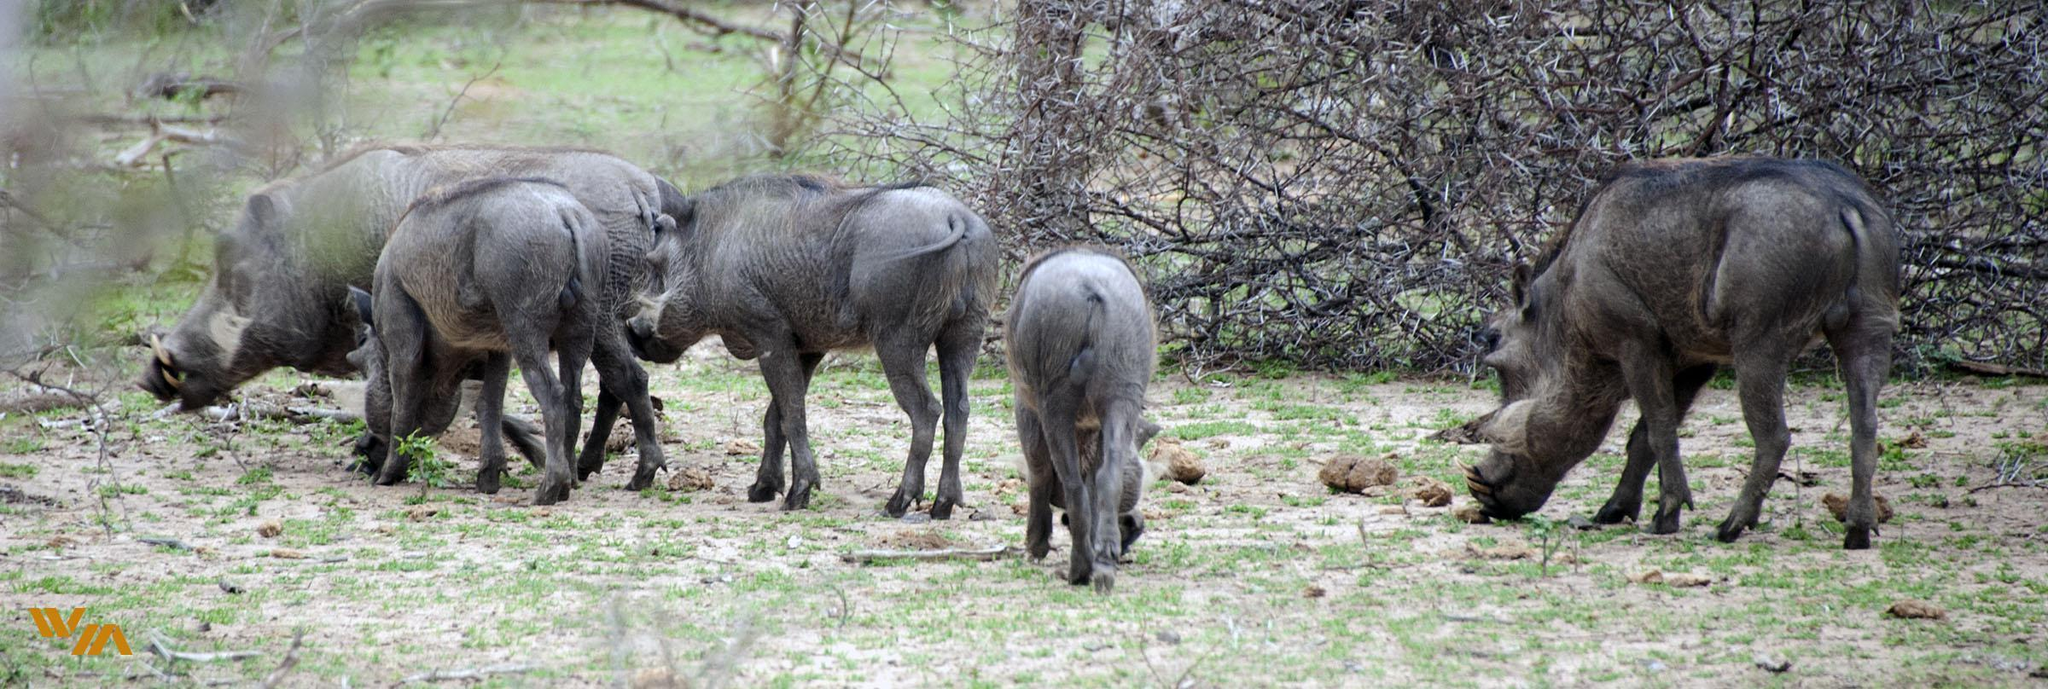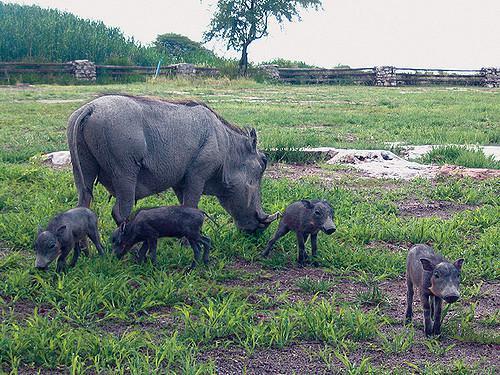The first image is the image on the left, the second image is the image on the right. Assess this claim about the two images: "One of the images shows at least one adult boar with four or less babies.". Correct or not? Answer yes or no. Yes. 